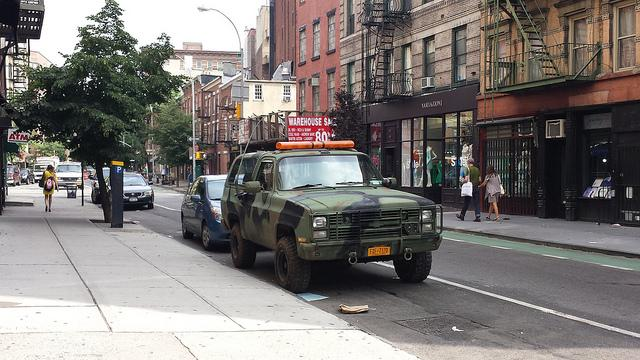Why does the truck have sign on top? Please explain your reasoning. advertising. The truck has an ad. 